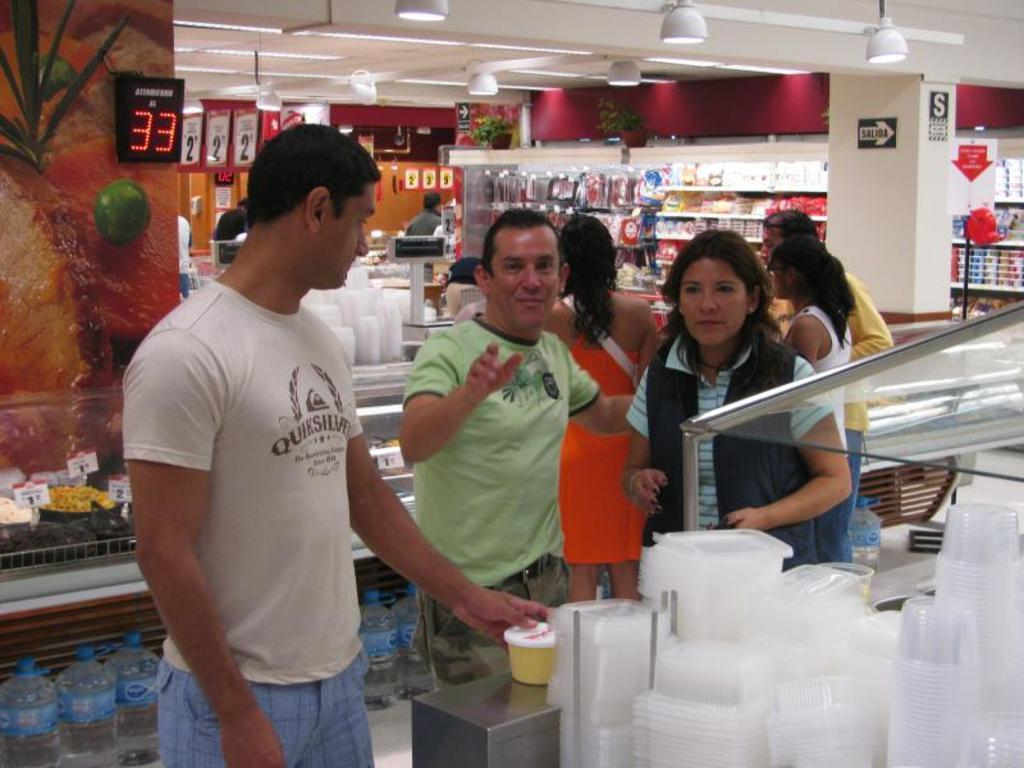How many people are in the image? There is a group of people in the image. Where are the people located? The people are standing in a shopping store. What can be found on the shelves in the store? There are groceries on the shelves in the store. What is visible on the roof of the store? There are lights on the roof of the store. What other objects can be seen in the store? There are other objects visible in the store. What type of trousers is the rat wearing in the image? There is no rat present in the image, and therefore no trousers can be observed. Is the scarf visible in the image? The facts provided do not mention a scarf, so it cannot be determined if it is present in the image. 